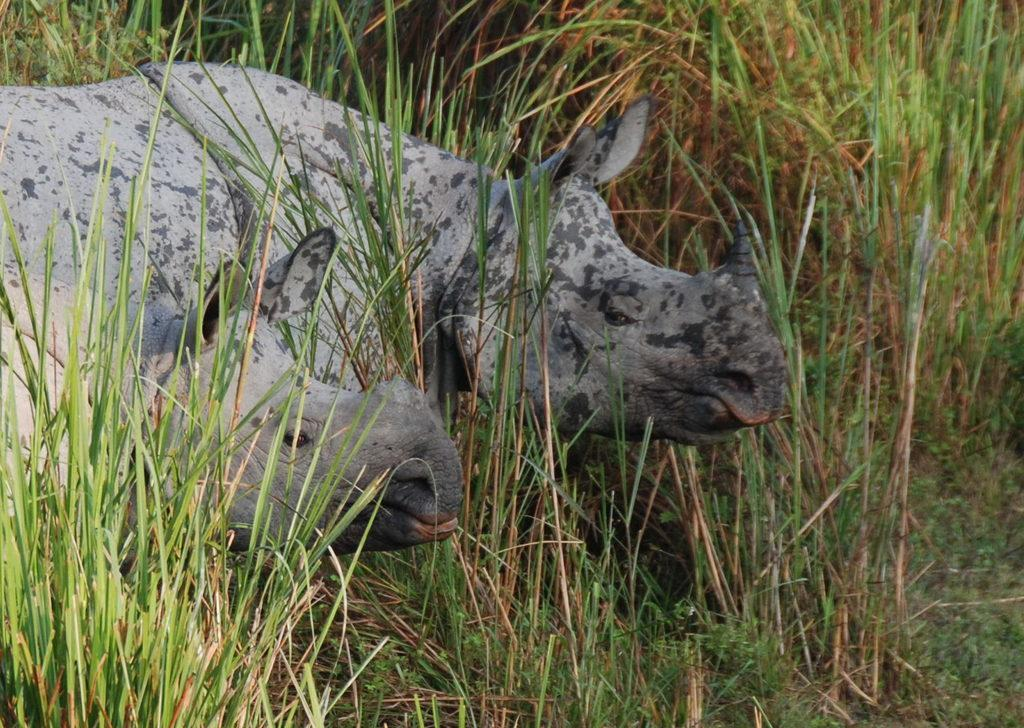How many hippopotamuses are in the image? There are two hippopotamuses in the image. What are the hippopotamuses doing in the image? The hippopotamuses are standing on the ground. What type of vegetation can be seen in the image? There are plants in the image. What is covering the ground in the image? There is grass on the ground in the image. What type of cactus can be seen in the image? There is no cactus present in the image; it features two hippopotamuses standing on grass with plants nearby. Can you tell me how many kettles are visible in the image? There are no kettles visible in the image. 